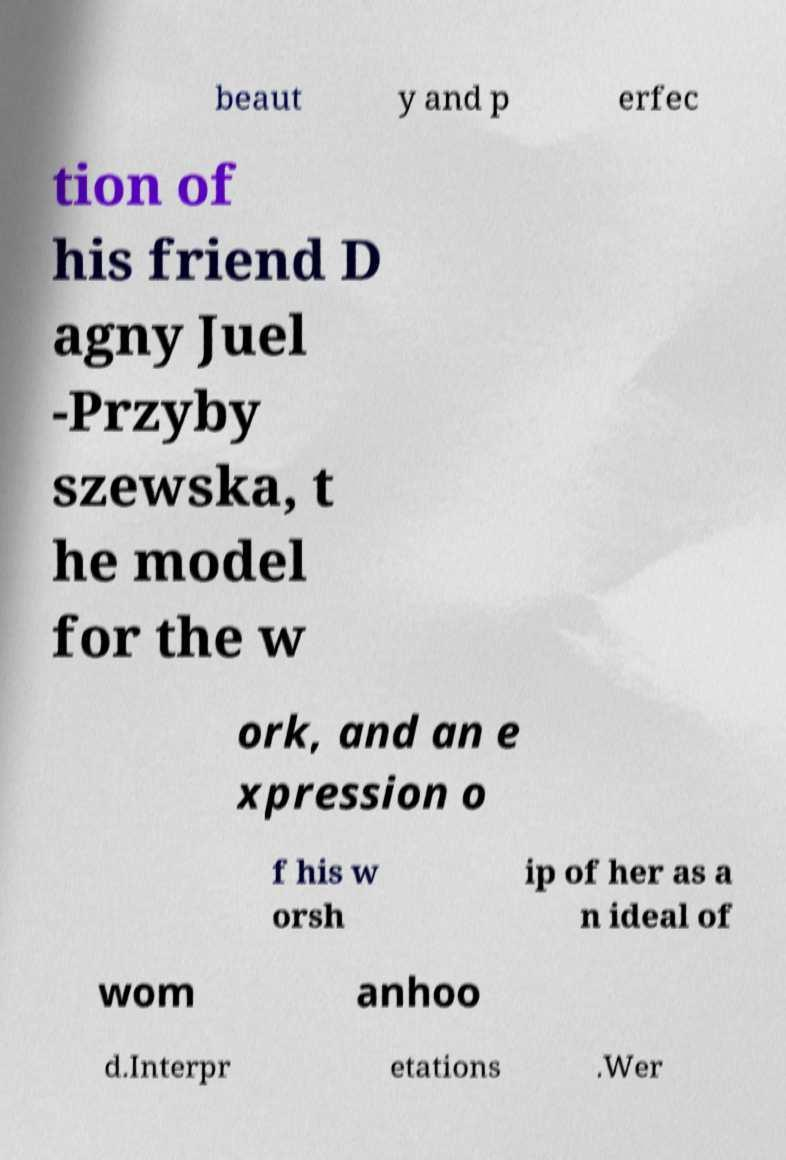Could you assist in decoding the text presented in this image and type it out clearly? beaut y and p erfec tion of his friend D agny Juel -Przyby szewska, t he model for the w ork, and an e xpression o f his w orsh ip of her as a n ideal of wom anhoo d.Interpr etations .Wer 